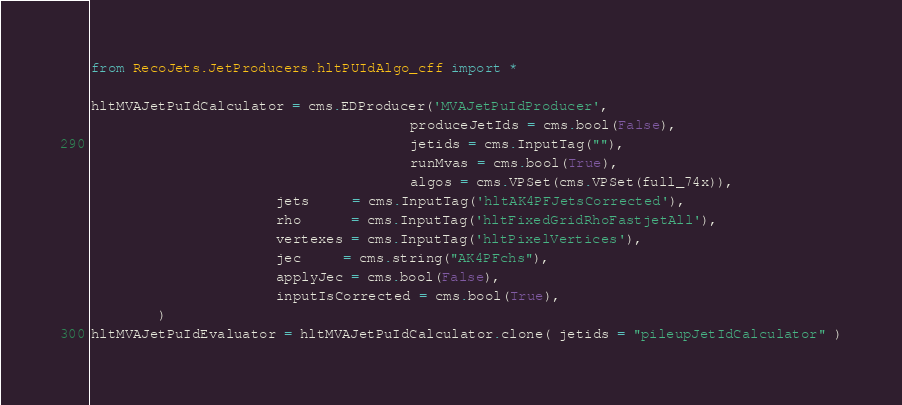Convert code to text. <code><loc_0><loc_0><loc_500><loc_500><_Python_>from RecoJets.JetProducers.hltPUIdAlgo_cff import *

hltMVAJetPuIdCalculator = cms.EDProducer('MVAJetPuIdProducer',
                                      produceJetIds = cms.bool(False),
                                      jetids = cms.InputTag(""),
                                      runMvas = cms.bool(True),
                                      algos = cms.VPSet(cms.VPSet(full_74x)),
				      jets     = cms.InputTag('hltAK4PFJetsCorrected'),
				      rho      = cms.InputTag('hltFixedGridRhoFastjetAll'),
				      vertexes = cms.InputTag('hltPixelVertices'),
				      jec     = cms.string("AK4PFchs"),
				      applyJec = cms.bool(False),
				      inputIsCorrected = cms.bool(True),
		)
hltMVAJetPuIdEvaluator = hltMVAJetPuIdCalculator.clone( jetids = "pileupJetIdCalculator" )
</code> 